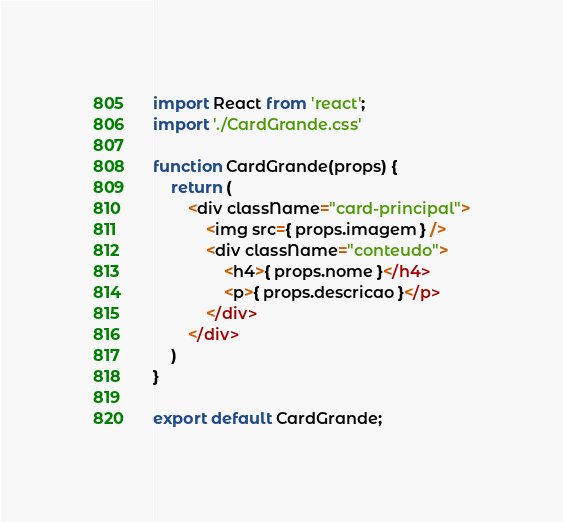Convert code to text. <code><loc_0><loc_0><loc_500><loc_500><_JavaScript_>import React from 'react';
import './CardGrande.css'

function CardGrande(props) {
    return (
        <div className="card-principal">
            <img src={ props.imagem } />
            <div className="conteudo">
                <h4>{ props.nome }</h4>
                <p>{ props.descricao }</p>
            </div>
        </div>
    )
}

export default CardGrande;</code> 